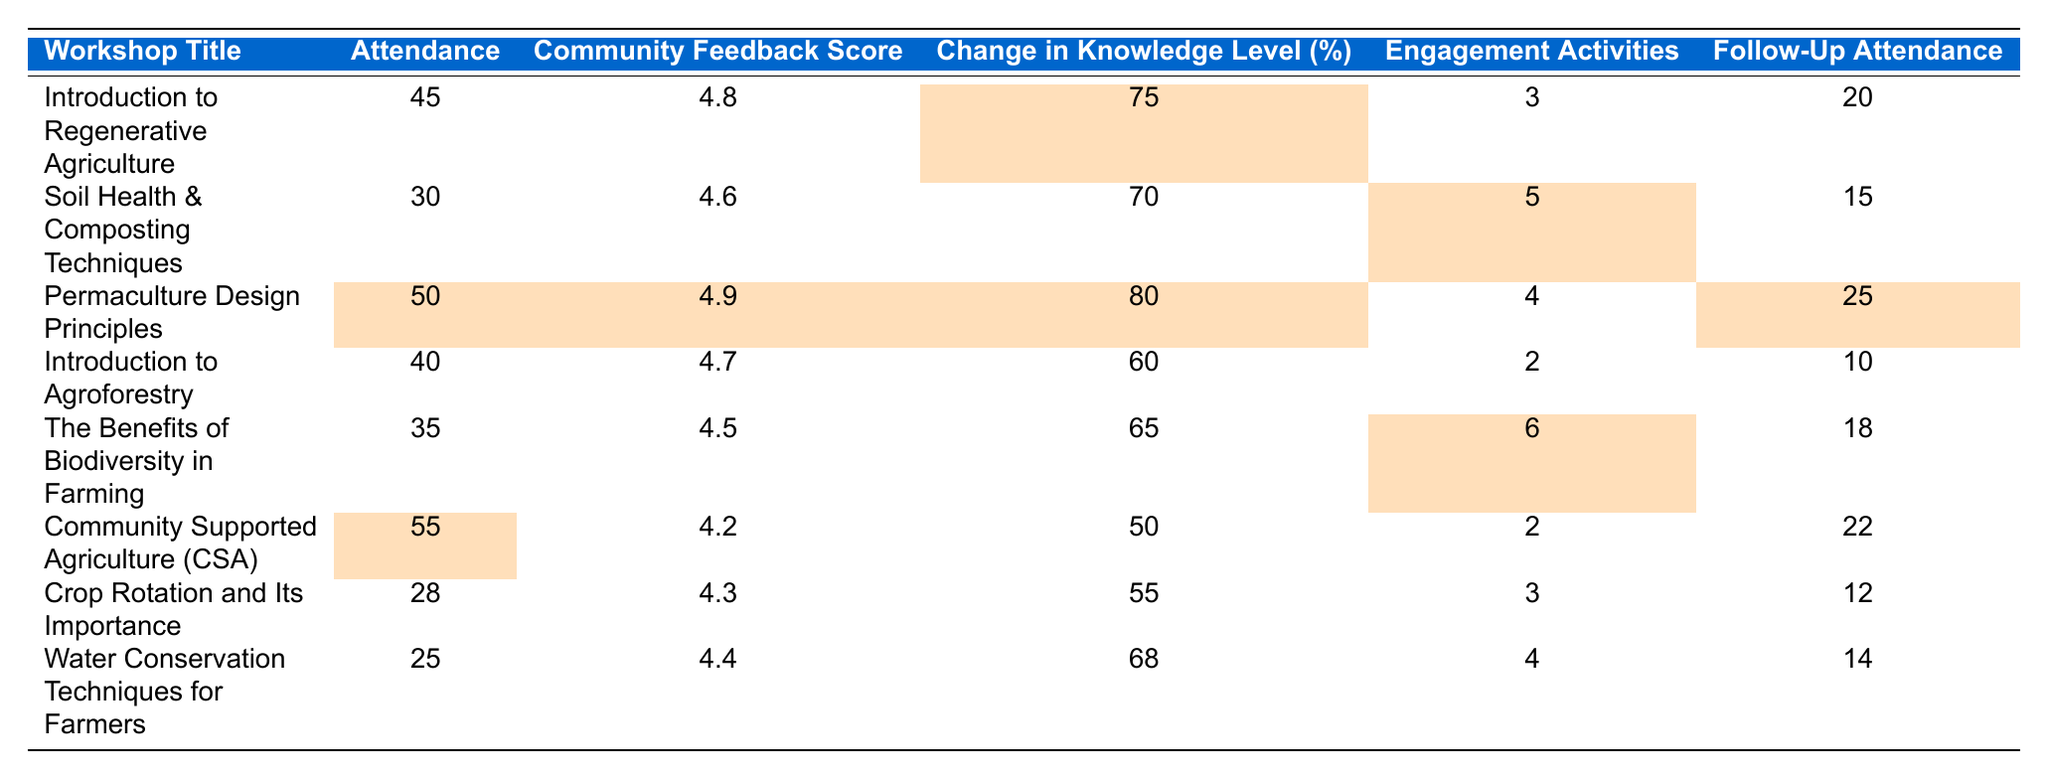What's the highest Community Feedback Score? The table shows the Community Feedback Scores for each workshop. The highest value is 4.9 for the "Permaculture Design Principles" workshop.
Answer: 4.9 Which workshop had the lowest attendance? The attendance figures are listed for each workshop. The lowest attendance is 25, for the "Water Conservation Techniques for Farmers" workshop.
Answer: 25 How many engagement activities were conducted in total across all workshops? Summing the Engagement Activities column (3 + 5 + 4 + 2 + 6 + 2 + 3 + 4) results in 29 engagement activities conducted in total.
Answer: 29 Which workshop had the highest change in knowledge level? Comparing the values in the Change in Knowledge Level column, the highest value is 80, which corresponds to the "Permaculture Design Principles" workshop.
Answer: 80 Did "Community Supported Agriculture (CSA)" have a higher Community Feedback Score than the average of all workshops? The average Community Feedback Score can be calculated by adding all the scores (4.8 + 4.6 + 4.9 + 4.7 + 4.5 + 4.2 + 4.3 + 4.4) and dividing by 8. This gives an average of 4.525, which is lower than the score of 4.2 for "Community Supported Agriculture (CSA)," thus the answer is no.
Answer: No What is the total follow-up attendance from all workshops? Summing the Follow-Up Attendance column (20 + 15 + 25 + 10 + 18 + 22 + 12 + 14) gives a total follow-up attendance of 126 across all workshops.
Answer: 126 Which workshops had more than 40 attendees? The workshops with more than 40 attendees are "Introduction to Regenerative Agriculture" (45), "Permaculture Design Principles" (50), and "Community Supported Agriculture (CSA)" (55).
Answer: 3 What percentage of participants followed up after the "Introduction to Regenerative Agriculture" workshop? The follow-up attendance is 20 and the total attendance is 45. The percentage is calculated as (20/45) * 100 = 44.44%, which can be rounded to approximately 44% for clarity.
Answer: 44% Which workshop had the most engagement activities? From the Engagement Activities column, the highest number is 6 for "The Benefits of Biodiversity in Farming."
Answer: 6 What is the median Change in Knowledge Level for the workshops? The Change in Knowledge Level values (75, 70, 80, 60, 65, 50, 55, 68) sorted in ascending order are 50, 55, 60, 65, 68, 70, 75, 80. The median, being the average of the two middle numbers (65 and 68), results in 66.5.
Answer: 66.5 